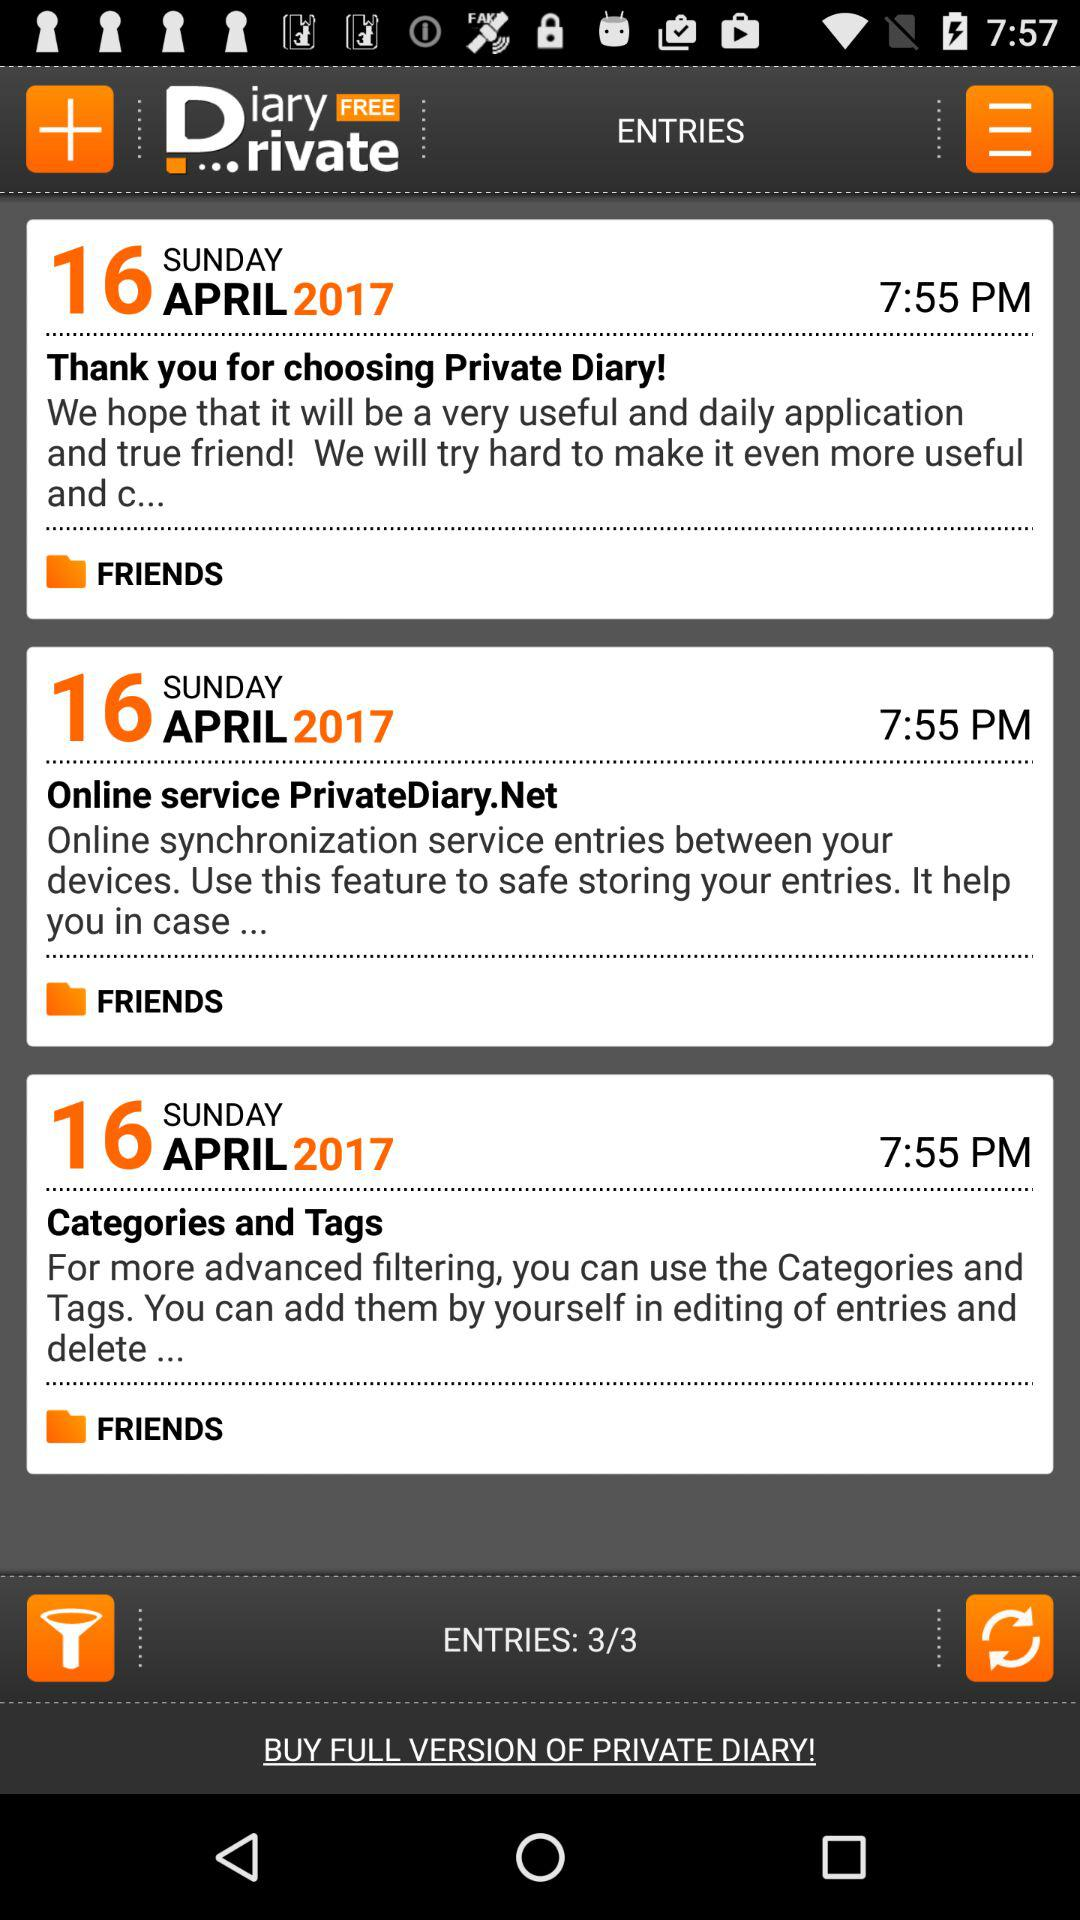How many more entries are there after the first entry?
Answer the question using a single word or phrase. 2 